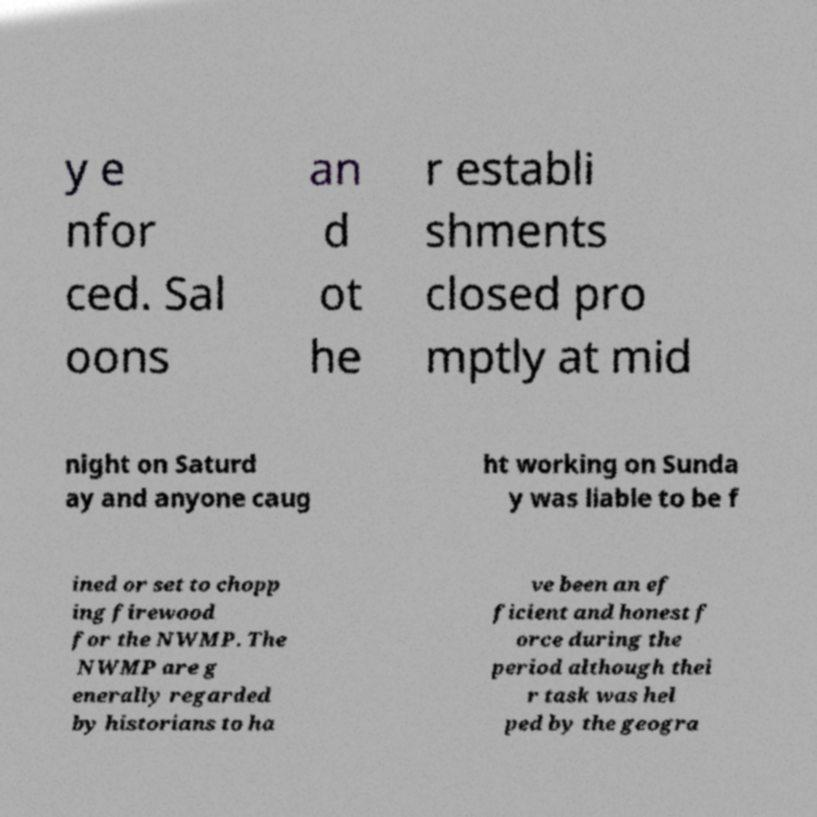What messages or text are displayed in this image? I need them in a readable, typed format. y e nfor ced. Sal oons an d ot he r establi shments closed pro mptly at mid night on Saturd ay and anyone caug ht working on Sunda y was liable to be f ined or set to chopp ing firewood for the NWMP. The NWMP are g enerally regarded by historians to ha ve been an ef ficient and honest f orce during the period although thei r task was hel ped by the geogra 